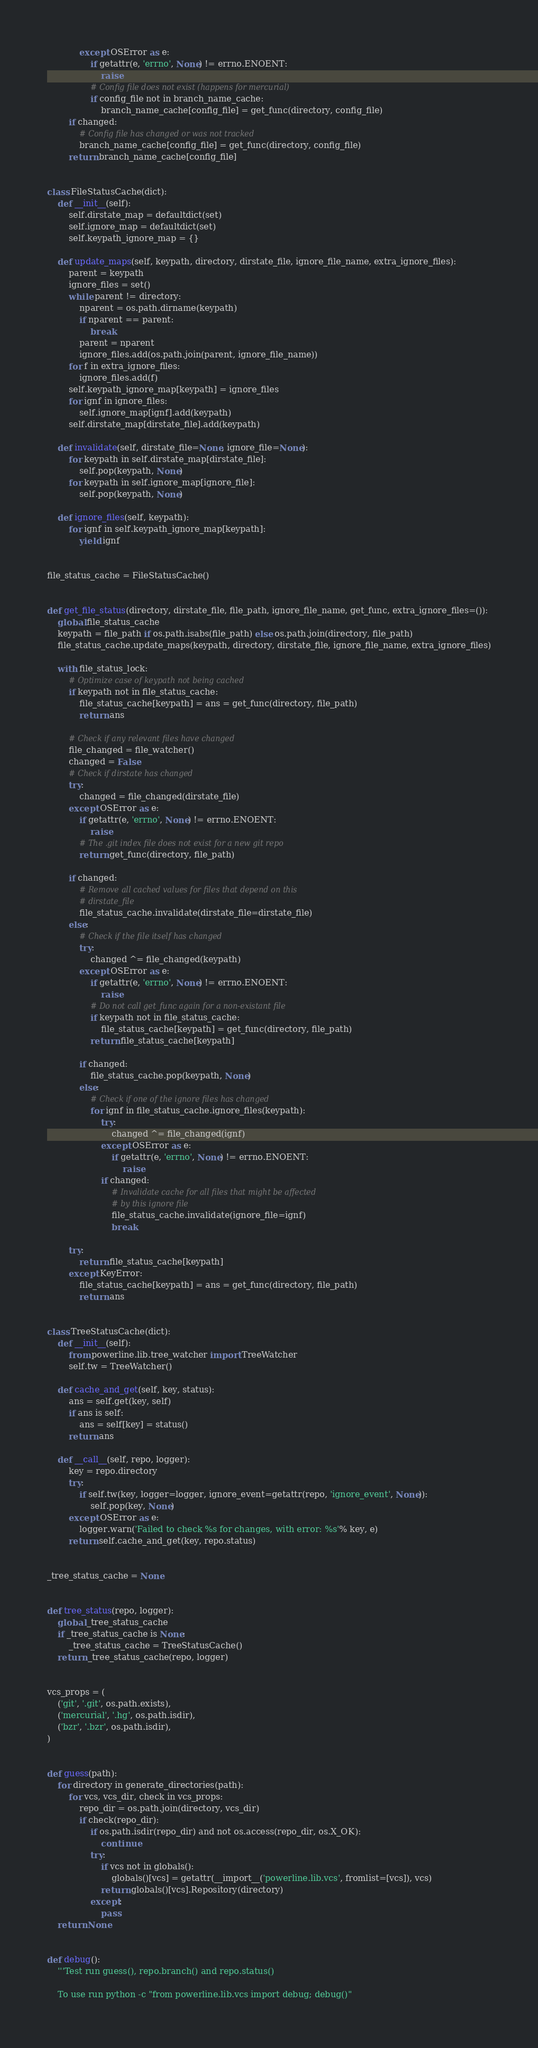Convert code to text. <code><loc_0><loc_0><loc_500><loc_500><_Python_>			except OSError as e:
				if getattr(e, 'errno', None) != errno.ENOENT:
					raise
				# Config file does not exist (happens for mercurial)
				if config_file not in branch_name_cache:
					branch_name_cache[config_file] = get_func(directory, config_file)
		if changed:
			# Config file has changed or was not tracked
			branch_name_cache[config_file] = get_func(directory, config_file)
		return branch_name_cache[config_file]


class FileStatusCache(dict):
	def __init__(self):
		self.dirstate_map = defaultdict(set)
		self.ignore_map = defaultdict(set)
		self.keypath_ignore_map = {}

	def update_maps(self, keypath, directory, dirstate_file, ignore_file_name, extra_ignore_files):
		parent = keypath
		ignore_files = set()
		while parent != directory:
			nparent = os.path.dirname(keypath)
			if nparent == parent:
				break
			parent = nparent
			ignore_files.add(os.path.join(parent, ignore_file_name))
		for f in extra_ignore_files:
			ignore_files.add(f)
		self.keypath_ignore_map[keypath] = ignore_files
		for ignf in ignore_files:
			self.ignore_map[ignf].add(keypath)
		self.dirstate_map[dirstate_file].add(keypath)

	def invalidate(self, dirstate_file=None, ignore_file=None):
		for keypath in self.dirstate_map[dirstate_file]:
			self.pop(keypath, None)
		for keypath in self.ignore_map[ignore_file]:
			self.pop(keypath, None)

	def ignore_files(self, keypath):
		for ignf in self.keypath_ignore_map[keypath]:
			yield ignf


file_status_cache = FileStatusCache()


def get_file_status(directory, dirstate_file, file_path, ignore_file_name, get_func, extra_ignore_files=()):
	global file_status_cache
	keypath = file_path if os.path.isabs(file_path) else os.path.join(directory, file_path)
	file_status_cache.update_maps(keypath, directory, dirstate_file, ignore_file_name, extra_ignore_files)

	with file_status_lock:
		# Optimize case of keypath not being cached
		if keypath not in file_status_cache:
			file_status_cache[keypath] = ans = get_func(directory, file_path)
			return ans

		# Check if any relevant files have changed
		file_changed = file_watcher()
		changed = False
		# Check if dirstate has changed
		try:
			changed = file_changed(dirstate_file)
		except OSError as e:
			if getattr(e, 'errno', None) != errno.ENOENT:
				raise
			# The .git index file does not exist for a new git repo
			return get_func(directory, file_path)

		if changed:
			# Remove all cached values for files that depend on this
			# dirstate_file
			file_status_cache.invalidate(dirstate_file=dirstate_file)
		else:
			# Check if the file itself has changed
			try:
				changed ^= file_changed(keypath)
			except OSError as e:
				if getattr(e, 'errno', None) != errno.ENOENT:
					raise
				# Do not call get_func again for a non-existant file
				if keypath not in file_status_cache:
					file_status_cache[keypath] = get_func(directory, file_path)
				return file_status_cache[keypath]

			if changed:
				file_status_cache.pop(keypath, None)
			else:
				# Check if one of the ignore files has changed
				for ignf in file_status_cache.ignore_files(keypath):
					try:
						changed ^= file_changed(ignf)
					except OSError as e:
						if getattr(e, 'errno', None) != errno.ENOENT:
							raise
					if changed:
						# Invalidate cache for all files that might be affected
						# by this ignore file
						file_status_cache.invalidate(ignore_file=ignf)
						break

		try:
			return file_status_cache[keypath]
		except KeyError:
			file_status_cache[keypath] = ans = get_func(directory, file_path)
			return ans


class TreeStatusCache(dict):
	def __init__(self):
		from powerline.lib.tree_watcher import TreeWatcher
		self.tw = TreeWatcher()

	def cache_and_get(self, key, status):
		ans = self.get(key, self)
		if ans is self:
			ans = self[key] = status()
		return ans

	def __call__(self, repo, logger):
		key = repo.directory
		try:
			if self.tw(key, logger=logger, ignore_event=getattr(repo, 'ignore_event', None)):
				self.pop(key, None)
		except OSError as e:
			logger.warn('Failed to check %s for changes, with error: %s'% key, e)
		return self.cache_and_get(key, repo.status)


_tree_status_cache = None


def tree_status(repo, logger):
	global _tree_status_cache
	if _tree_status_cache is None:
		_tree_status_cache = TreeStatusCache()
	return _tree_status_cache(repo, logger)


vcs_props = (
	('git', '.git', os.path.exists),
	('mercurial', '.hg', os.path.isdir),
	('bzr', '.bzr', os.path.isdir),
)


def guess(path):
	for directory in generate_directories(path):
		for vcs, vcs_dir, check in vcs_props:
			repo_dir = os.path.join(directory, vcs_dir)
			if check(repo_dir):
				if os.path.isdir(repo_dir) and not os.access(repo_dir, os.X_OK):
					continue
				try:
					if vcs not in globals():
						globals()[vcs] = getattr(__import__('powerline.lib.vcs', fromlist=[vcs]), vcs)
					return globals()[vcs].Repository(directory)
				except:
					pass
	return None


def debug():
	'''Test run guess(), repo.branch() and repo.status()

	To use run python -c "from powerline.lib.vcs import debug; debug()" </code> 